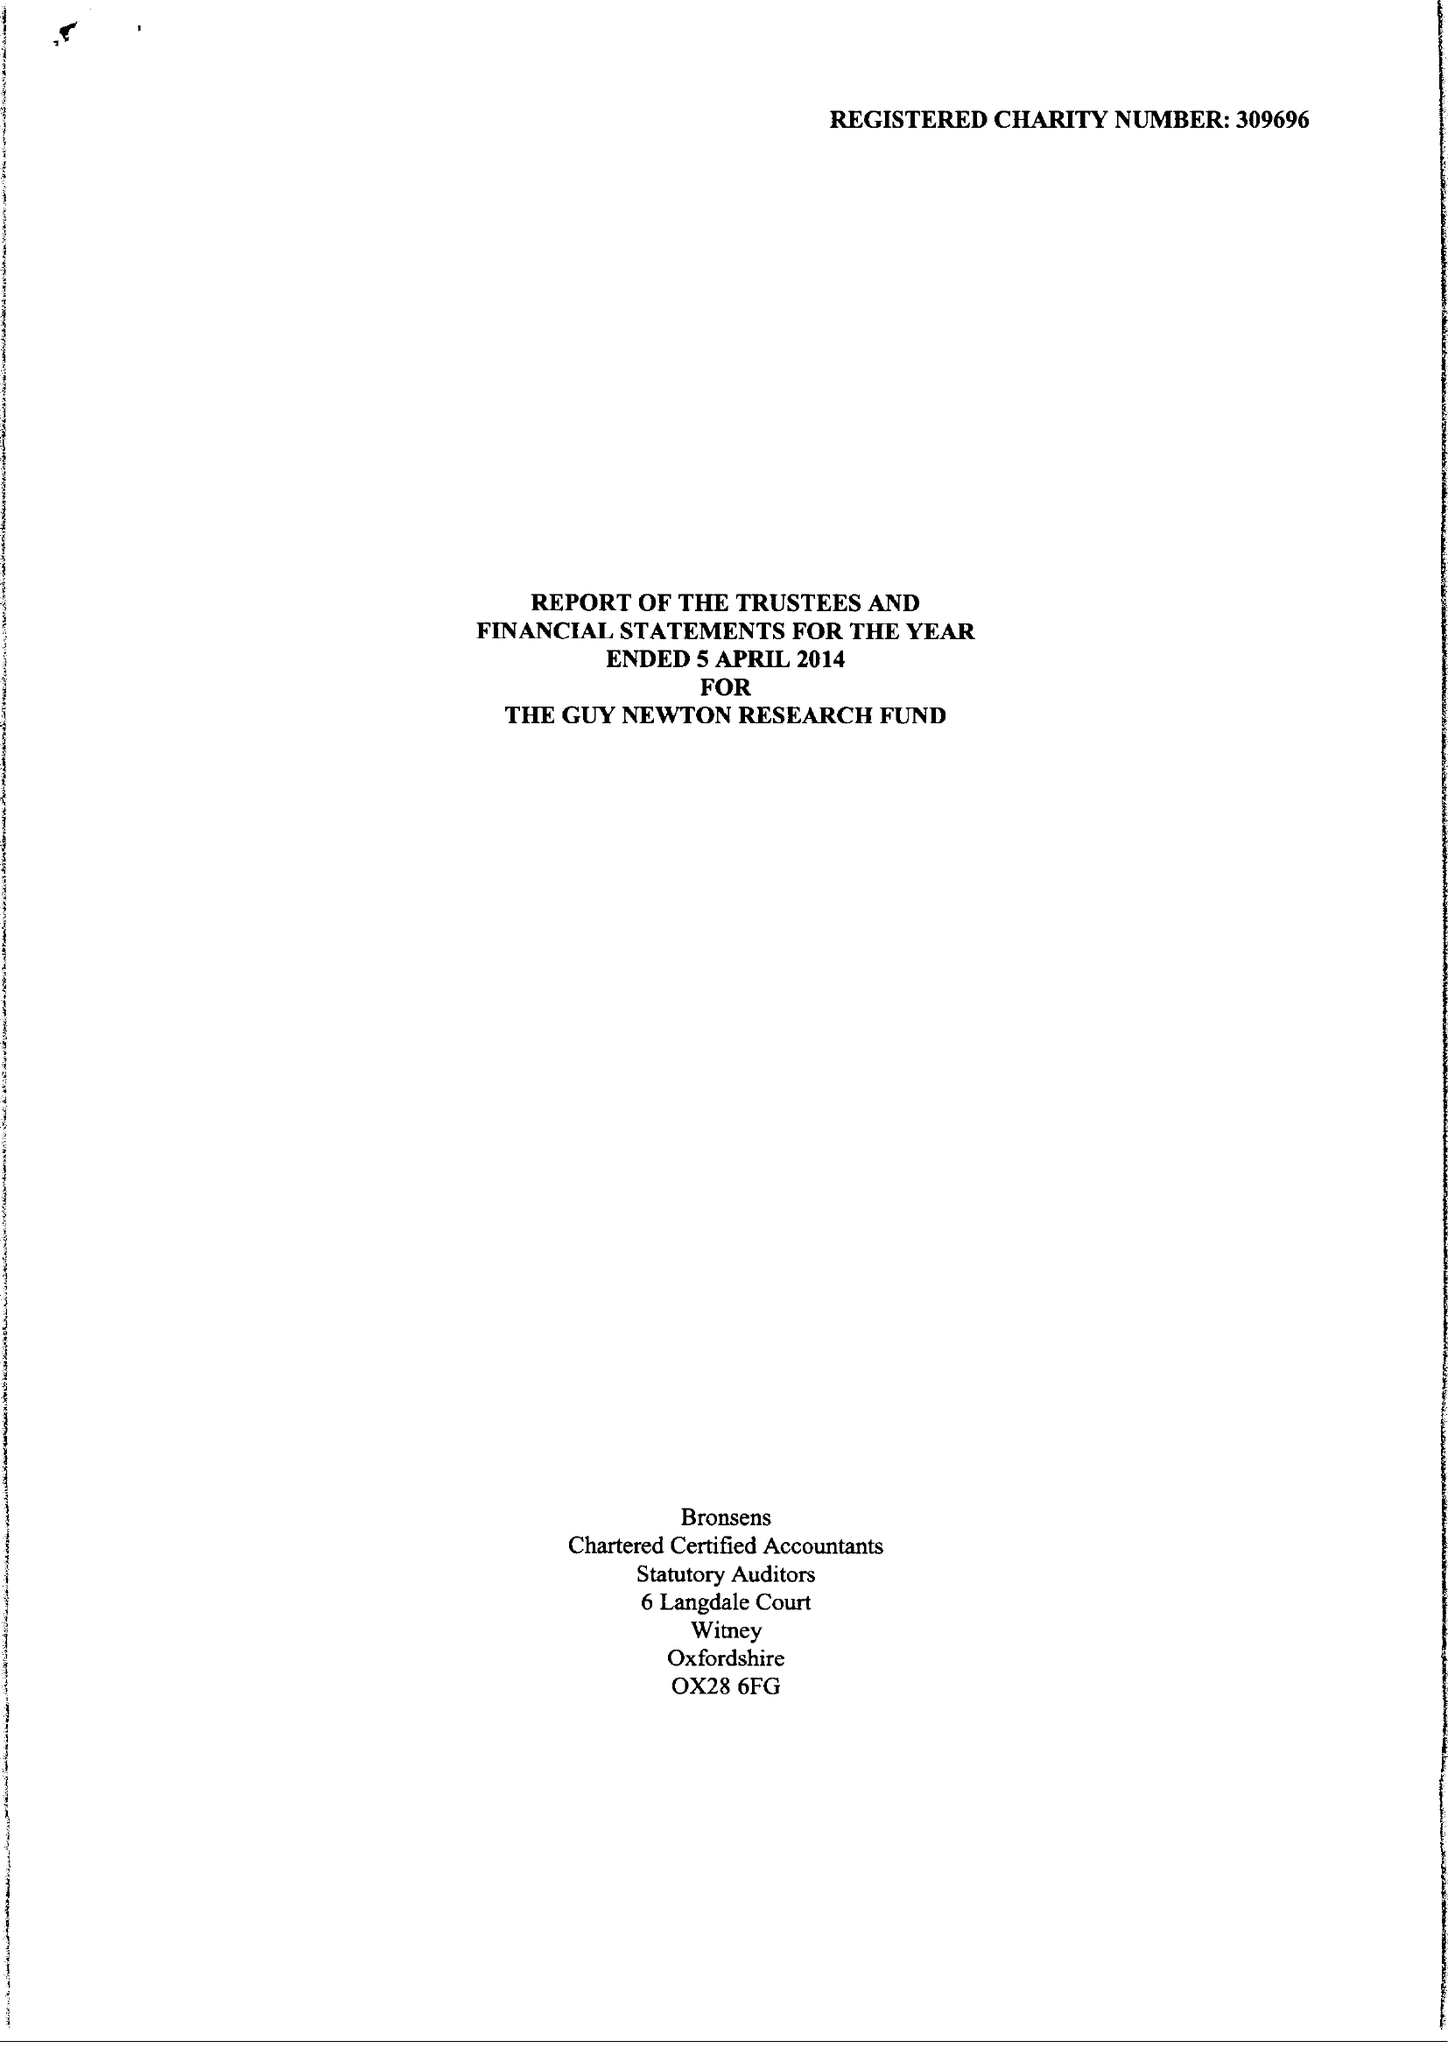What is the value for the charity_number?
Answer the question using a single word or phrase. 309696 